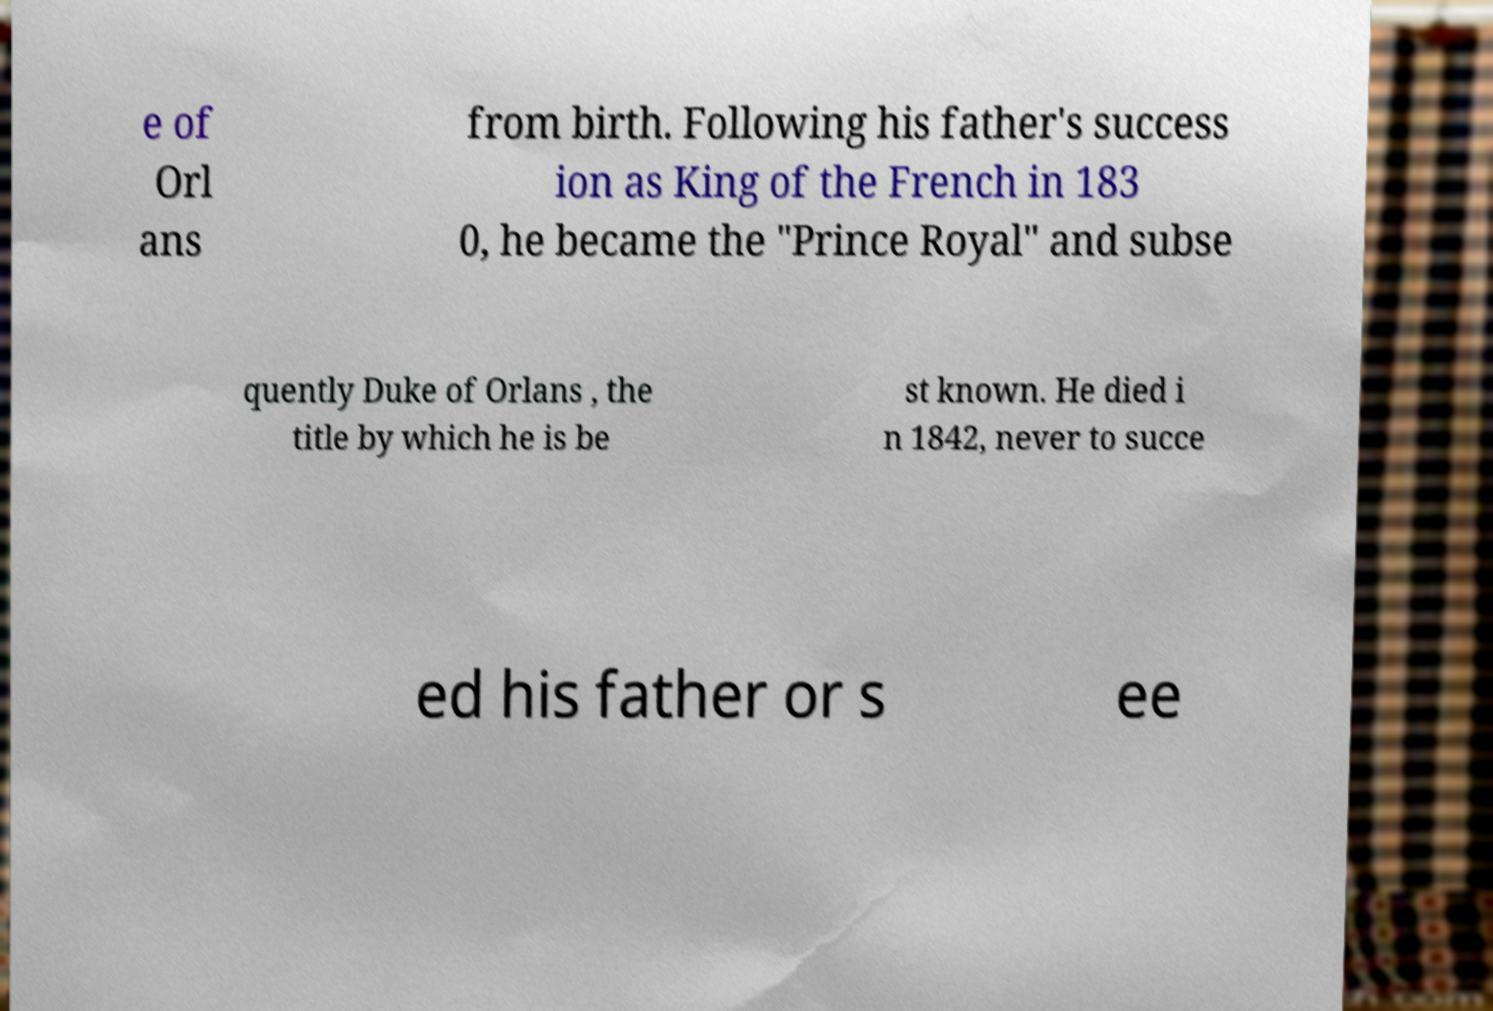Please identify and transcribe the text found in this image. e of Orl ans from birth. Following his father's success ion as King of the French in 183 0, he became the "Prince Royal" and subse quently Duke of Orlans , the title by which he is be st known. He died i n 1842, never to succe ed his father or s ee 